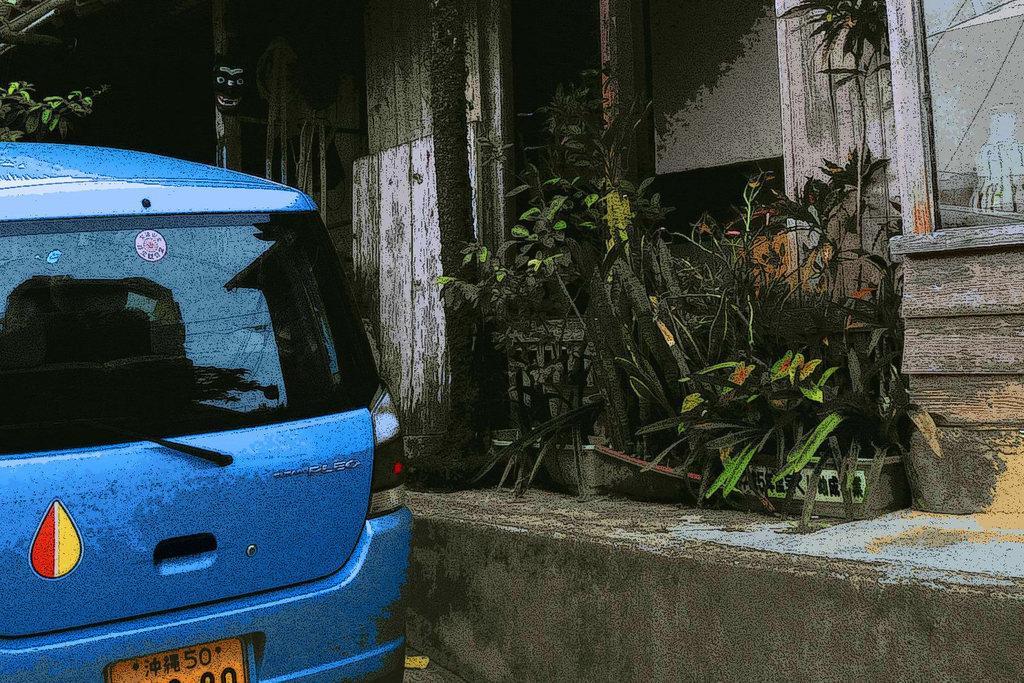In one or two sentences, can you explain what this image depicts? In the picture I can see a car on the left side. I can see a house and there is a glass window on the top right side. I can see the plants and there is a scarecrow mask on the wooden pole of a house. 